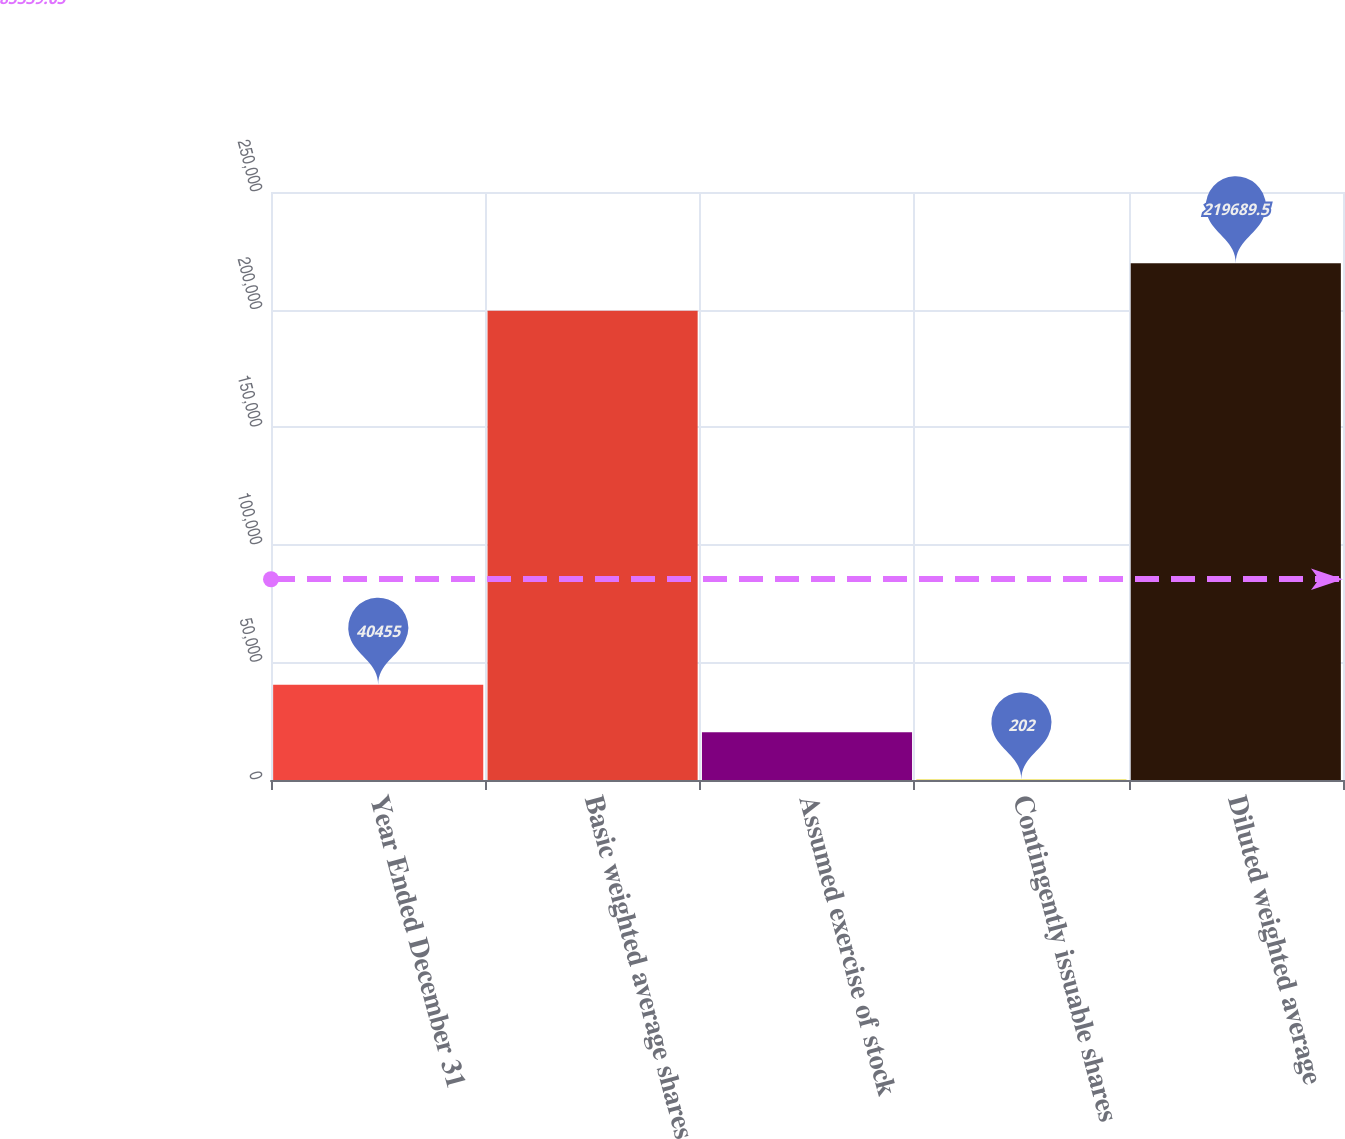Convert chart to OTSL. <chart><loc_0><loc_0><loc_500><loc_500><bar_chart><fcel>Year Ended December 31<fcel>Basic weighted average shares<fcel>Assumed exercise of stock<fcel>Contingently issuable shares<fcel>Diluted weighted average<nl><fcel>40455<fcel>199563<fcel>20328.5<fcel>202<fcel>219690<nl></chart> 